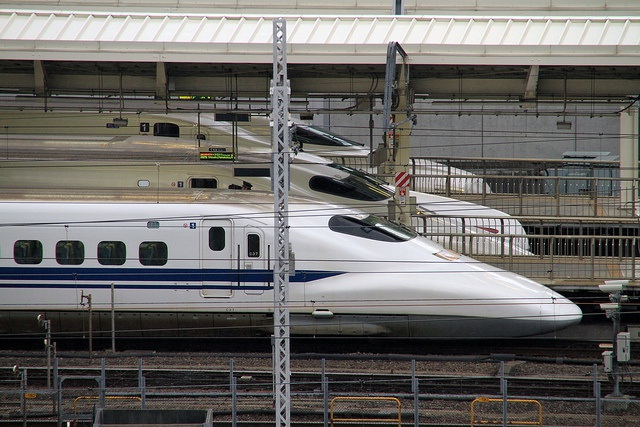Describe the objects in this image and their specific colors. I can see train in gray, darkgray, lightgray, and black tones, train in gray, black, and darkgray tones, and train in gray, darkgray, black, and lightgray tones in this image. 